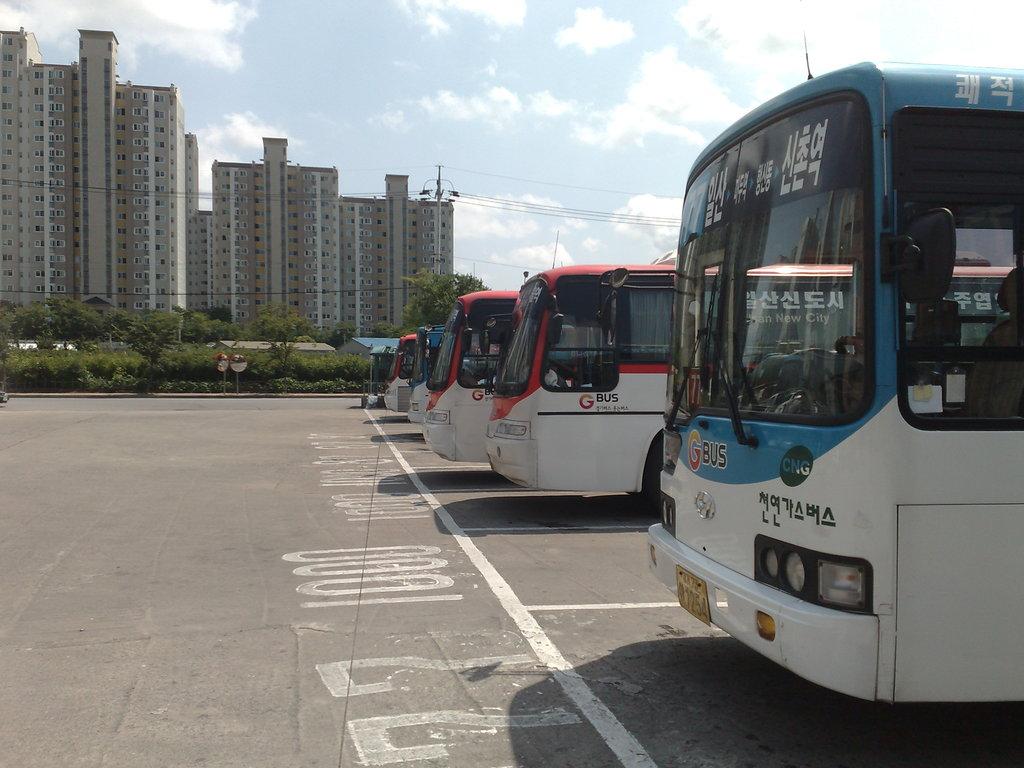What parking spot is the first train in?
Keep it short and to the point. 77. What lane number is the first bus parked in?
Ensure brevity in your answer.  77. 